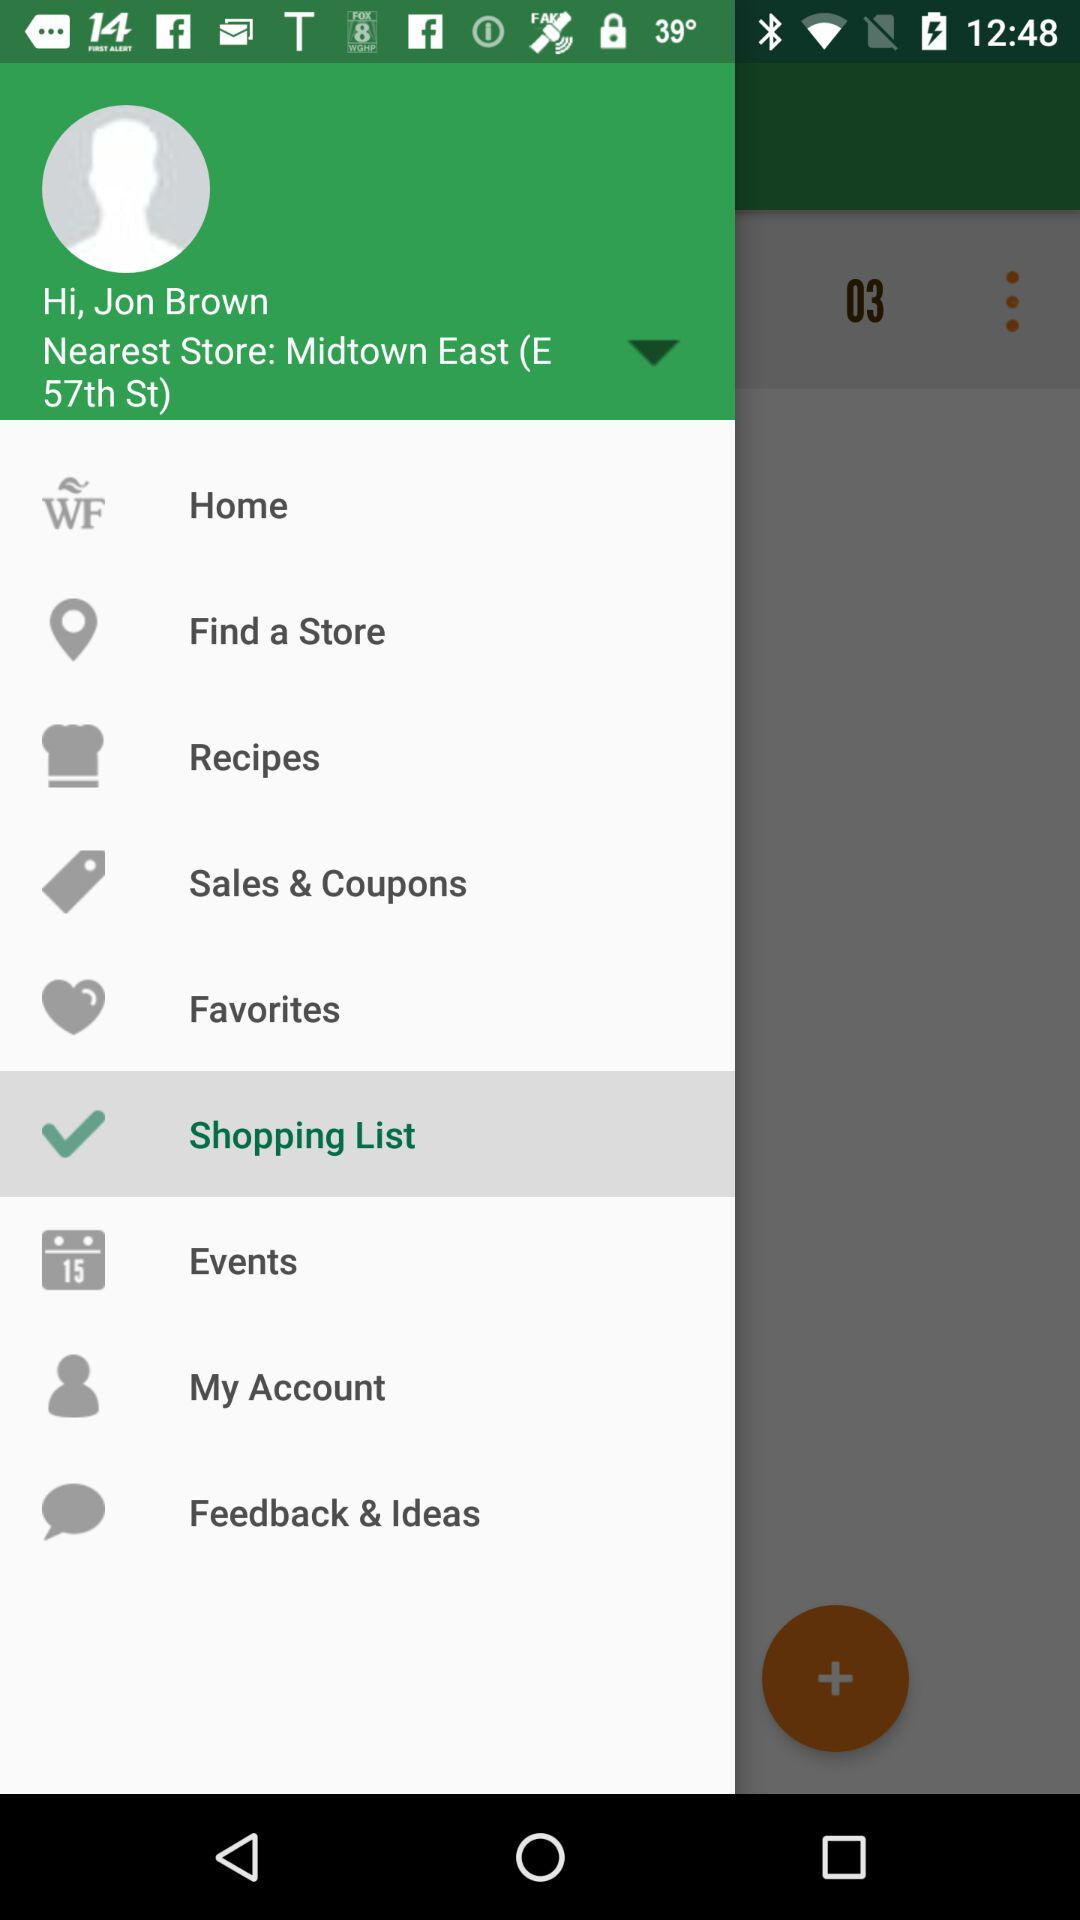What is the event date?
When the provided information is insufficient, respond with <no answer>. <no answer> 